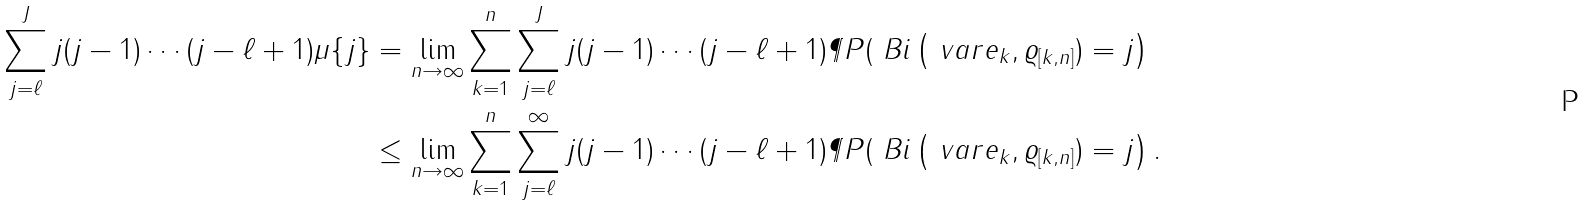Convert formula to latex. <formula><loc_0><loc_0><loc_500><loc_500>\sum _ { j = \ell } ^ { J } j ( j - 1 ) \cdots ( j - \ell + 1 ) \mu \{ j \} & = \lim _ { n \to \infty } \sum _ { k = 1 } ^ { n } \sum _ { j = \ell } ^ { J } j ( j - 1 ) \cdots ( j - \ell + 1 ) \P P ( \ B i \left ( \ v a r e _ { k } , \varrho _ { [ k , n ] } ) = j \right ) \\ & \leq \lim _ { n \to \infty } \sum _ { k = 1 } ^ { n } \sum _ { j = \ell } ^ { \infty } j ( j - 1 ) \cdots ( j - \ell + 1 ) \P P ( \ B i \left ( \ v a r e _ { k } , \varrho _ { [ k , n ] } ) = j \right ) .</formula> 